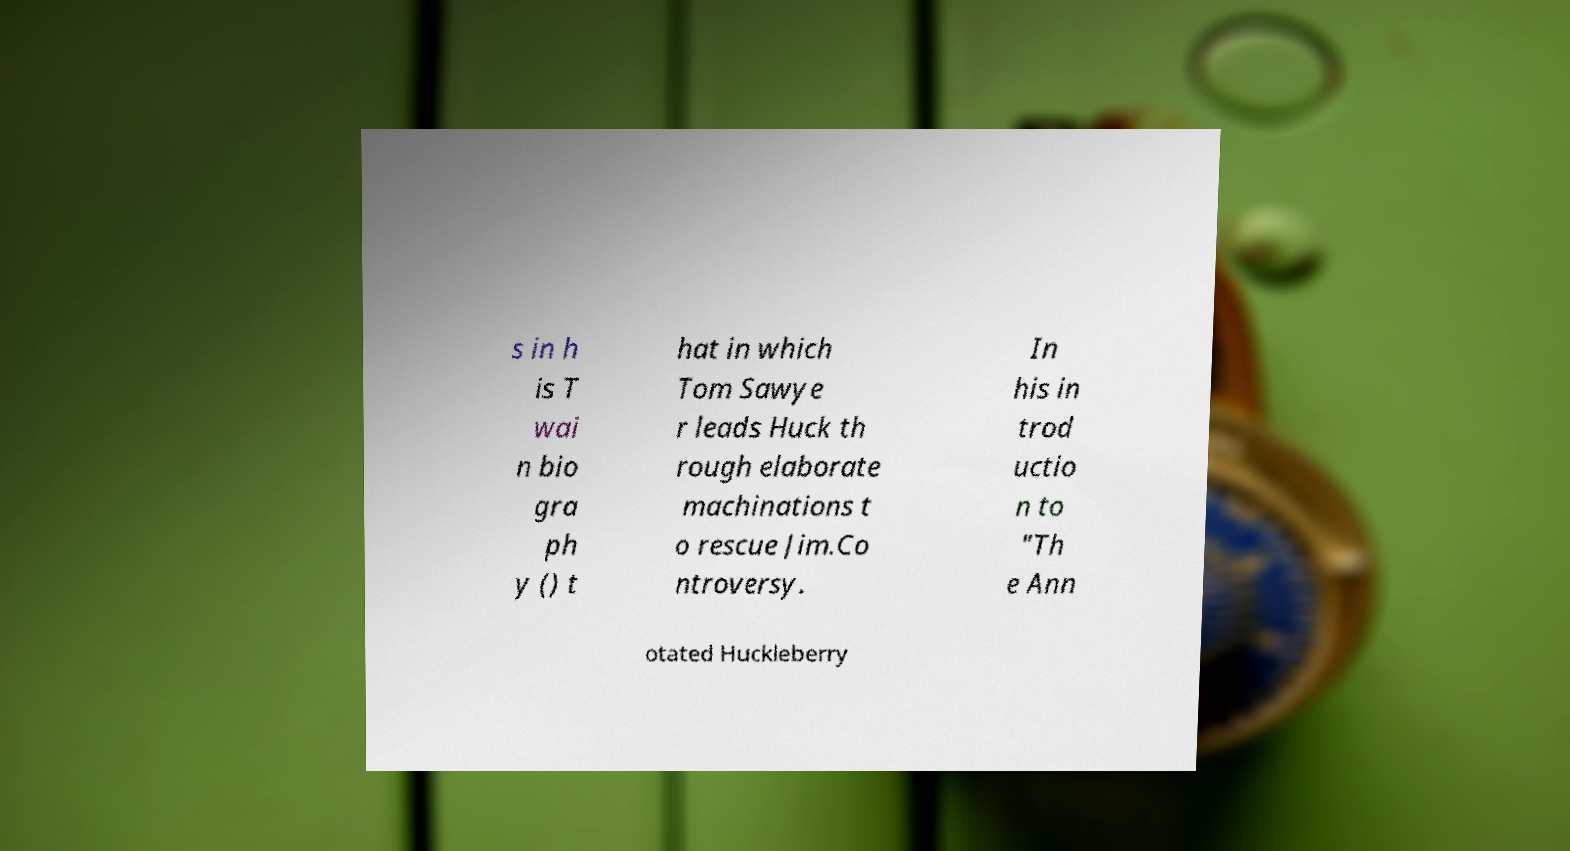Please identify and transcribe the text found in this image. s in h is T wai n bio gra ph y () t hat in which Tom Sawye r leads Huck th rough elaborate machinations t o rescue Jim.Co ntroversy. In his in trod uctio n to "Th e Ann otated Huckleberry 